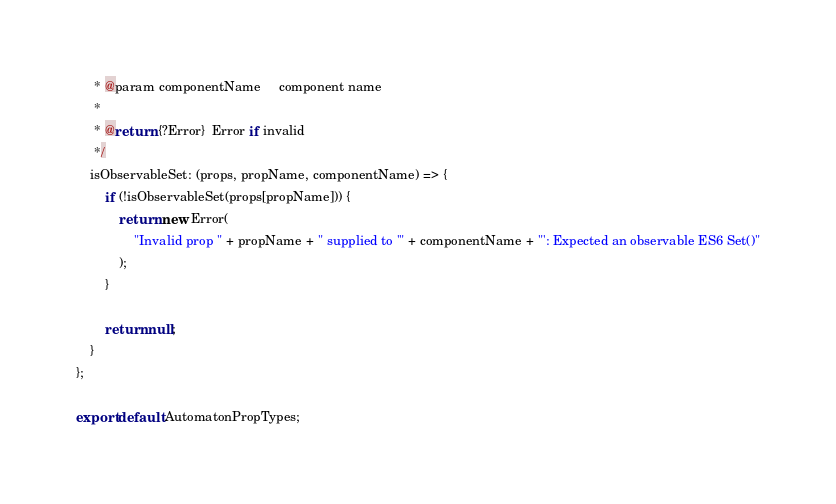<code> <loc_0><loc_0><loc_500><loc_500><_JavaScript_>     * @param componentName     component name
     *
     * @return {?Error}  Error if invalid
     */
    isObservableSet: (props, propName, componentName) => {
        if (!isObservableSet(props[propName])) {
            return new Error(
                "Invalid prop " + propName + " supplied to '" + componentName + "': Expected an observable ES6 Set()"
            );
        }

        return null;
    }
};

export default AutomatonPropTypes;
</code> 